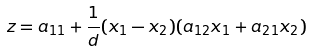Convert formula to latex. <formula><loc_0><loc_0><loc_500><loc_500>z = a _ { 1 1 } + \frac { 1 } { d } ( x _ { 1 } - x _ { 2 } ) ( a _ { 1 2 } x _ { 1 } + a _ { 2 1 } x _ { 2 } )</formula> 